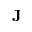<formula> <loc_0><loc_0><loc_500><loc_500>J</formula> 